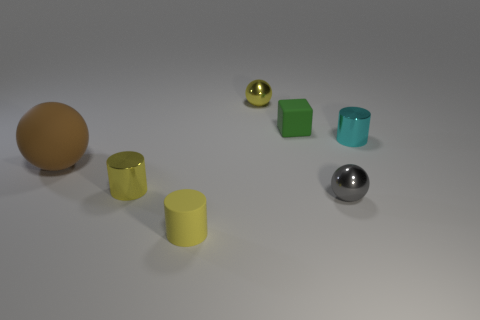Is there any other thing that has the same size as the brown thing?
Make the answer very short. No. Does the brown matte thing have the same shape as the small cyan object?
Offer a terse response. No. The cube has what color?
Offer a very short reply. Green. What number of objects are either small cyan rubber cubes or cylinders?
Your answer should be very brief. 3. Is there any other thing that is made of the same material as the block?
Your answer should be very brief. Yes. Is the number of large brown rubber objects to the right of the brown sphere less than the number of matte cubes?
Keep it short and to the point. Yes. Are there more cylinders in front of the large brown thing than gray metallic objects behind the green object?
Offer a terse response. Yes. Are there any other things that are the same color as the big matte ball?
Ensure brevity in your answer.  No. What is the cylinder that is in front of the gray metallic thing made of?
Provide a succinct answer. Rubber. Do the rubber cube and the yellow metal ball have the same size?
Provide a short and direct response. Yes. 